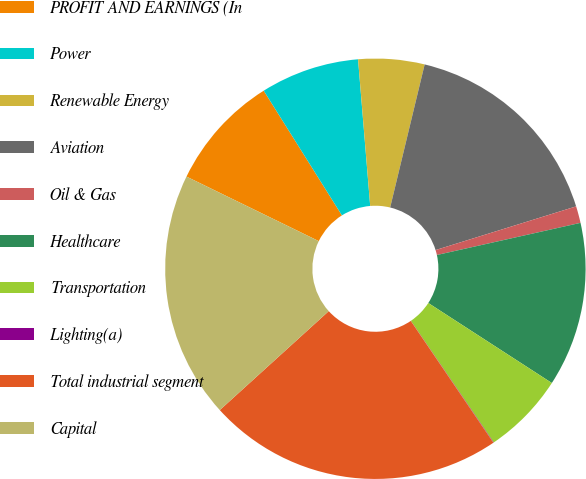Convert chart. <chart><loc_0><loc_0><loc_500><loc_500><pie_chart><fcel>PROFIT AND EARNINGS (In<fcel>Power<fcel>Renewable Energy<fcel>Aviation<fcel>Oil & Gas<fcel>Healthcare<fcel>Transportation<fcel>Lighting(a)<fcel>Total industrial segment<fcel>Capital<nl><fcel>8.86%<fcel>7.6%<fcel>5.08%<fcel>16.44%<fcel>1.29%<fcel>12.65%<fcel>6.34%<fcel>0.03%<fcel>22.75%<fcel>18.96%<nl></chart> 